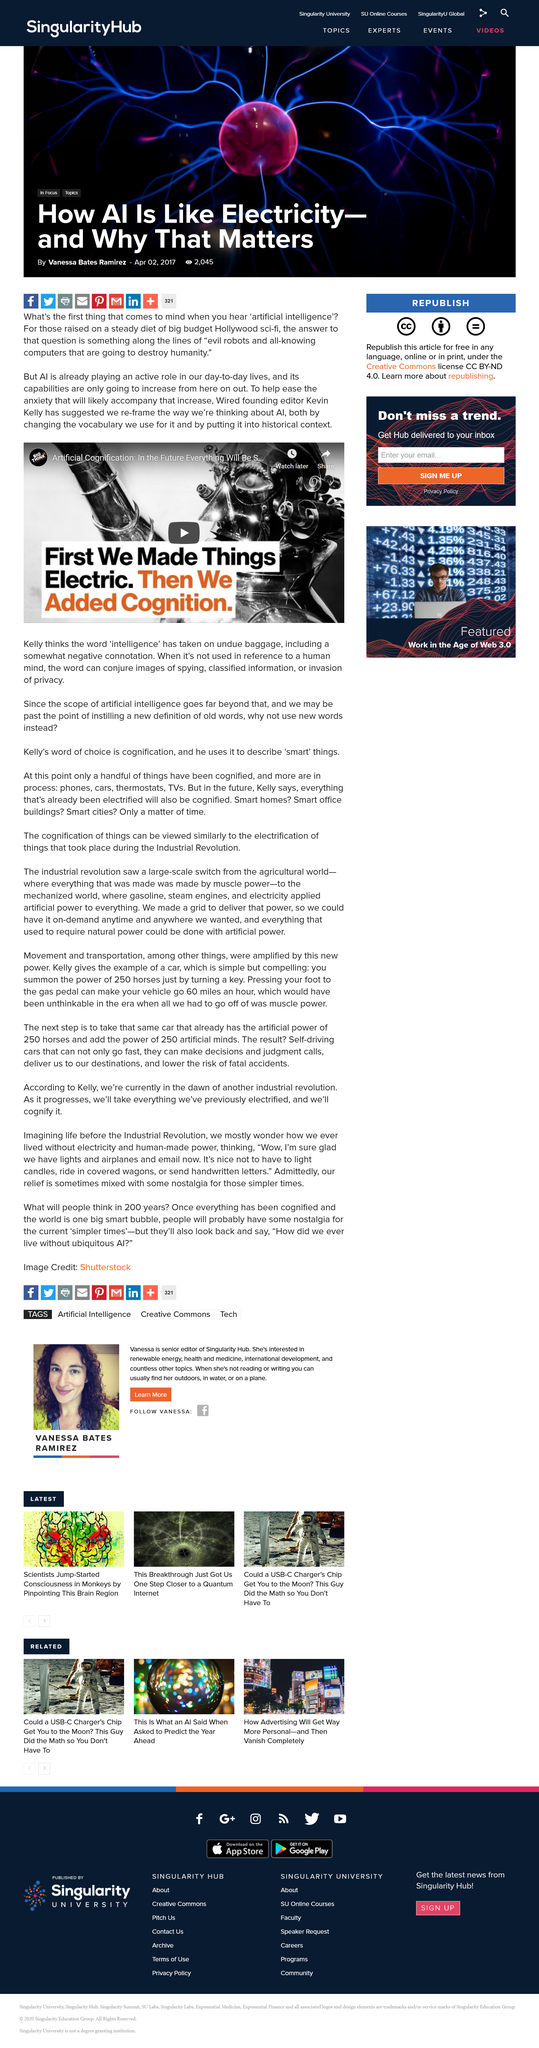Point out several critical features in this image. In this article, AI stands for Artificial Intelligence. Kevin suggested that we re-frame the way we think about AI by changing the vocabulary we use for it and by putting it into historical context. Kevin Kelly is the founding editor of Wired magazine. 